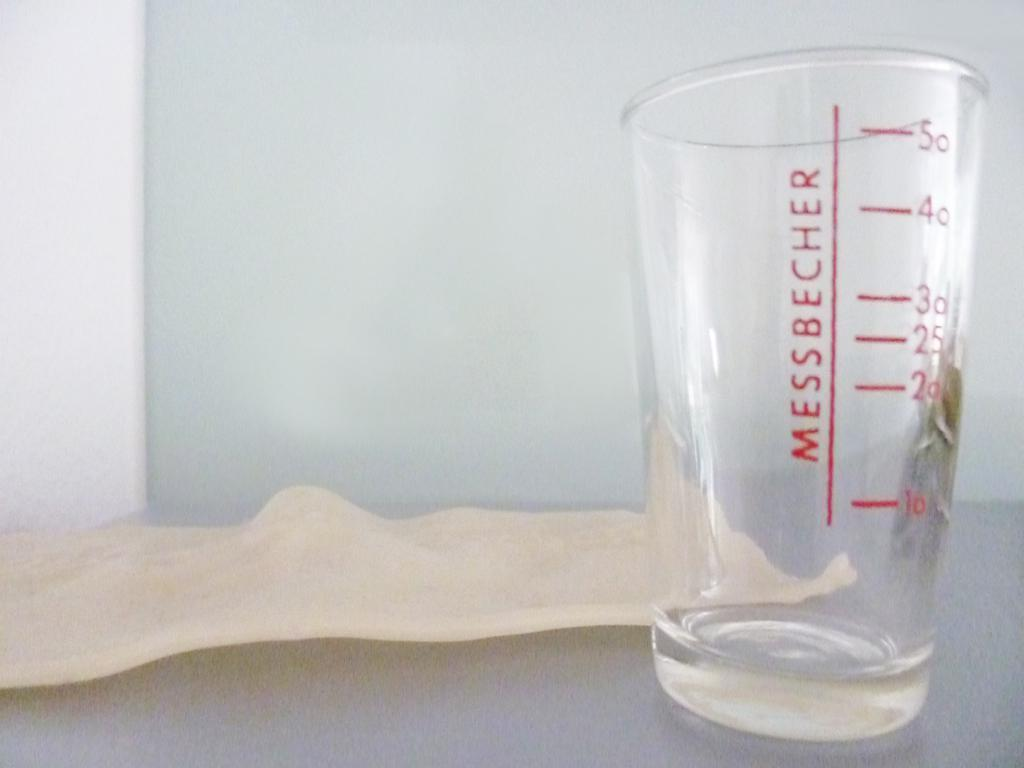<image>
Create a compact narrative representing the image presented. A messbecher measuring cup that goes up to 50 is empty 